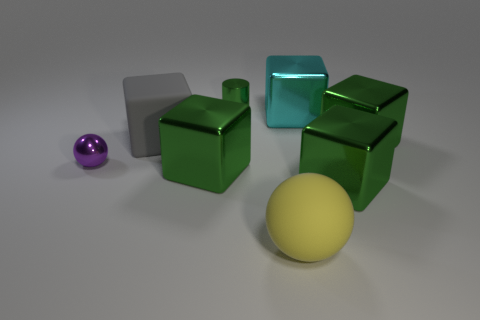There is a cube that is behind the purple thing and left of the small cylinder; what color is it?
Provide a short and direct response. Gray. How many big cyan blocks are left of the green cube that is left of the yellow matte object?
Keep it short and to the point. 0. What is the material of the big gray thing that is the same shape as the cyan object?
Ensure brevity in your answer.  Rubber. The tiny metallic ball is what color?
Make the answer very short. Purple. How many things are either small red rubber objects or cubes?
Make the answer very short. 5. What shape is the large matte object to the left of the large shiny thing that is on the left side of the green cylinder?
Give a very brief answer. Cube. How many other objects are the same material as the gray thing?
Give a very brief answer. 1. Are the large yellow sphere and the cyan block that is to the right of the big yellow matte thing made of the same material?
Give a very brief answer. No. How many things are either green things in front of the tiny green metallic object or large rubber things behind the tiny purple thing?
Offer a terse response. 4. How many other objects are the same color as the small metal cylinder?
Offer a terse response. 3. 